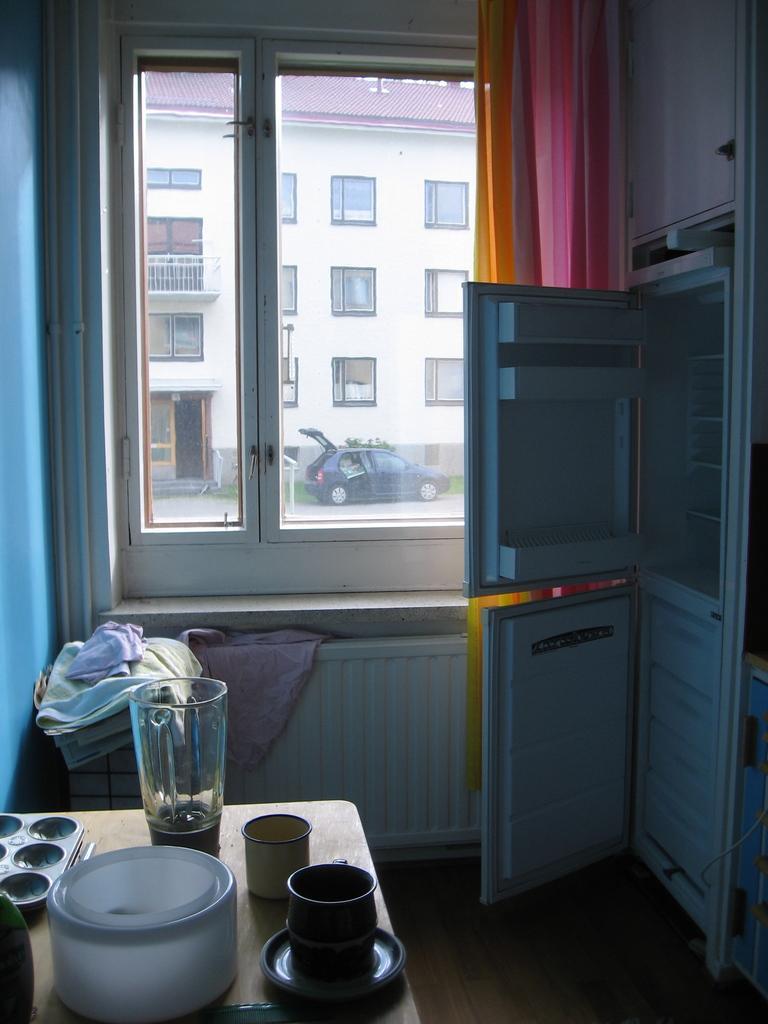Could you give a brief overview of what you see in this image? In the image we can see the internal view of the room. Here we can see a refrigerator, cup, container and other things. Here we can see clothes, the window, curtains and the floor. Out of the window we can see the building and the windows of the building, we can even see the vehicle, grass and the road. 